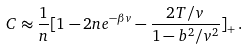Convert formula to latex. <formula><loc_0><loc_0><loc_500><loc_500>C \approx \frac { 1 } { n } [ 1 - 2 n e ^ { - \beta v } - \frac { 2 T / v } { 1 - b ^ { 2 } / v ^ { 2 } } ] _ { + } \, .</formula> 